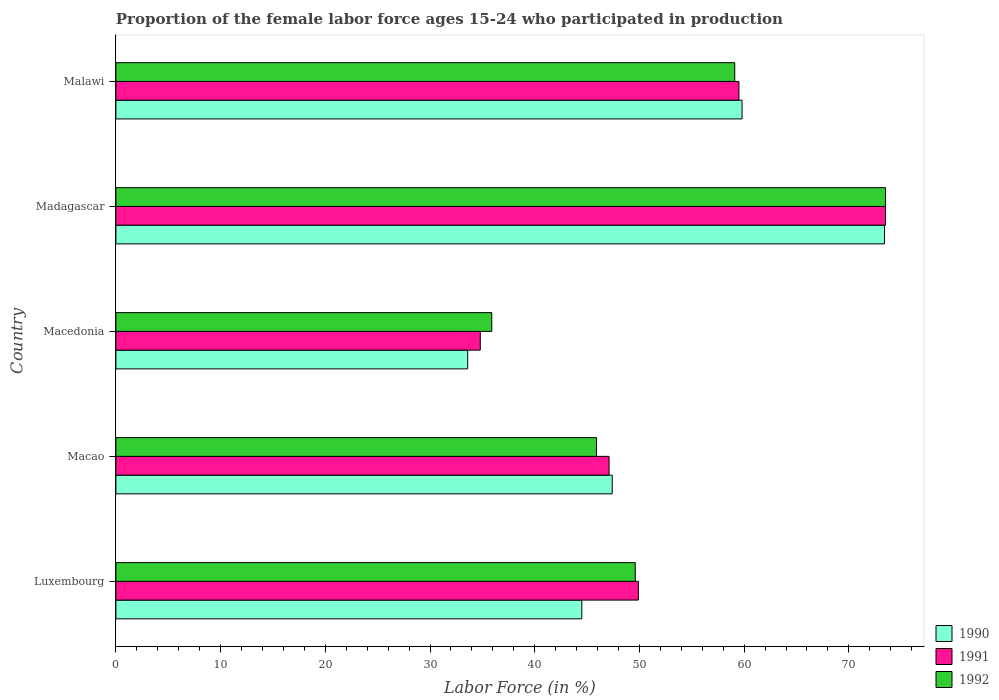Are the number of bars per tick equal to the number of legend labels?
Offer a terse response. Yes. What is the label of the 1st group of bars from the top?
Give a very brief answer. Malawi. What is the proportion of the female labor force who participated in production in 1990 in Macedonia?
Ensure brevity in your answer.  33.6. Across all countries, what is the maximum proportion of the female labor force who participated in production in 1992?
Your answer should be compact. 73.5. Across all countries, what is the minimum proportion of the female labor force who participated in production in 1992?
Provide a short and direct response. 35.9. In which country was the proportion of the female labor force who participated in production in 1990 maximum?
Make the answer very short. Madagascar. In which country was the proportion of the female labor force who participated in production in 1992 minimum?
Provide a short and direct response. Macedonia. What is the total proportion of the female labor force who participated in production in 1990 in the graph?
Give a very brief answer. 258.7. What is the difference between the proportion of the female labor force who participated in production in 1991 in Macao and that in Macedonia?
Provide a succinct answer. 12.3. What is the difference between the proportion of the female labor force who participated in production in 1992 in Malawi and the proportion of the female labor force who participated in production in 1991 in Macedonia?
Provide a short and direct response. 24.3. What is the average proportion of the female labor force who participated in production in 1990 per country?
Your response must be concise. 51.74. What is the difference between the proportion of the female labor force who participated in production in 1990 and proportion of the female labor force who participated in production in 1991 in Macedonia?
Offer a terse response. -1.2. What is the ratio of the proportion of the female labor force who participated in production in 1990 in Macao to that in Malawi?
Make the answer very short. 0.79. What is the difference between the highest and the second highest proportion of the female labor force who participated in production in 1990?
Offer a terse response. 13.6. What is the difference between the highest and the lowest proportion of the female labor force who participated in production in 1990?
Ensure brevity in your answer.  39.8. In how many countries, is the proportion of the female labor force who participated in production in 1992 greater than the average proportion of the female labor force who participated in production in 1992 taken over all countries?
Your answer should be very brief. 2. Is the sum of the proportion of the female labor force who participated in production in 1992 in Madagascar and Malawi greater than the maximum proportion of the female labor force who participated in production in 1990 across all countries?
Keep it short and to the point. Yes. What does the 3rd bar from the top in Madagascar represents?
Offer a very short reply. 1990. Is it the case that in every country, the sum of the proportion of the female labor force who participated in production in 1992 and proportion of the female labor force who participated in production in 1991 is greater than the proportion of the female labor force who participated in production in 1990?
Give a very brief answer. Yes. How many bars are there?
Make the answer very short. 15. How many countries are there in the graph?
Give a very brief answer. 5. What is the difference between two consecutive major ticks on the X-axis?
Provide a short and direct response. 10. Are the values on the major ticks of X-axis written in scientific E-notation?
Offer a terse response. No. Does the graph contain any zero values?
Give a very brief answer. No. Does the graph contain grids?
Your answer should be very brief. No. Where does the legend appear in the graph?
Your answer should be compact. Bottom right. How many legend labels are there?
Make the answer very short. 3. How are the legend labels stacked?
Make the answer very short. Vertical. What is the title of the graph?
Give a very brief answer. Proportion of the female labor force ages 15-24 who participated in production. Does "1969" appear as one of the legend labels in the graph?
Keep it short and to the point. No. What is the label or title of the X-axis?
Your answer should be compact. Labor Force (in %). What is the label or title of the Y-axis?
Make the answer very short. Country. What is the Labor Force (in %) of 1990 in Luxembourg?
Offer a terse response. 44.5. What is the Labor Force (in %) of 1991 in Luxembourg?
Provide a short and direct response. 49.9. What is the Labor Force (in %) of 1992 in Luxembourg?
Your response must be concise. 49.6. What is the Labor Force (in %) in 1990 in Macao?
Make the answer very short. 47.4. What is the Labor Force (in %) in 1991 in Macao?
Offer a terse response. 47.1. What is the Labor Force (in %) of 1992 in Macao?
Give a very brief answer. 45.9. What is the Labor Force (in %) of 1990 in Macedonia?
Make the answer very short. 33.6. What is the Labor Force (in %) in 1991 in Macedonia?
Give a very brief answer. 34.8. What is the Labor Force (in %) in 1992 in Macedonia?
Provide a short and direct response. 35.9. What is the Labor Force (in %) in 1990 in Madagascar?
Ensure brevity in your answer.  73.4. What is the Labor Force (in %) in 1991 in Madagascar?
Provide a short and direct response. 73.5. What is the Labor Force (in %) in 1992 in Madagascar?
Your answer should be very brief. 73.5. What is the Labor Force (in %) of 1990 in Malawi?
Your response must be concise. 59.8. What is the Labor Force (in %) in 1991 in Malawi?
Give a very brief answer. 59.5. What is the Labor Force (in %) in 1992 in Malawi?
Give a very brief answer. 59.1. Across all countries, what is the maximum Labor Force (in %) in 1990?
Provide a short and direct response. 73.4. Across all countries, what is the maximum Labor Force (in %) in 1991?
Provide a short and direct response. 73.5. Across all countries, what is the maximum Labor Force (in %) in 1992?
Your answer should be compact. 73.5. Across all countries, what is the minimum Labor Force (in %) in 1990?
Keep it short and to the point. 33.6. Across all countries, what is the minimum Labor Force (in %) of 1991?
Give a very brief answer. 34.8. Across all countries, what is the minimum Labor Force (in %) in 1992?
Your response must be concise. 35.9. What is the total Labor Force (in %) of 1990 in the graph?
Provide a short and direct response. 258.7. What is the total Labor Force (in %) of 1991 in the graph?
Give a very brief answer. 264.8. What is the total Labor Force (in %) of 1992 in the graph?
Provide a succinct answer. 264. What is the difference between the Labor Force (in %) in 1990 in Luxembourg and that in Macao?
Keep it short and to the point. -2.9. What is the difference between the Labor Force (in %) in 1991 in Luxembourg and that in Macao?
Your response must be concise. 2.8. What is the difference between the Labor Force (in %) of 1990 in Luxembourg and that in Macedonia?
Make the answer very short. 10.9. What is the difference between the Labor Force (in %) in 1991 in Luxembourg and that in Macedonia?
Give a very brief answer. 15.1. What is the difference between the Labor Force (in %) in 1990 in Luxembourg and that in Madagascar?
Provide a short and direct response. -28.9. What is the difference between the Labor Force (in %) of 1991 in Luxembourg and that in Madagascar?
Offer a terse response. -23.6. What is the difference between the Labor Force (in %) in 1992 in Luxembourg and that in Madagascar?
Keep it short and to the point. -23.9. What is the difference between the Labor Force (in %) of 1990 in Luxembourg and that in Malawi?
Provide a short and direct response. -15.3. What is the difference between the Labor Force (in %) in 1991 in Luxembourg and that in Malawi?
Provide a succinct answer. -9.6. What is the difference between the Labor Force (in %) of 1992 in Luxembourg and that in Malawi?
Make the answer very short. -9.5. What is the difference between the Labor Force (in %) in 1991 in Macao and that in Macedonia?
Your answer should be very brief. 12.3. What is the difference between the Labor Force (in %) in 1990 in Macao and that in Madagascar?
Ensure brevity in your answer.  -26. What is the difference between the Labor Force (in %) of 1991 in Macao and that in Madagascar?
Provide a succinct answer. -26.4. What is the difference between the Labor Force (in %) of 1992 in Macao and that in Madagascar?
Make the answer very short. -27.6. What is the difference between the Labor Force (in %) in 1990 in Macao and that in Malawi?
Your response must be concise. -12.4. What is the difference between the Labor Force (in %) of 1991 in Macao and that in Malawi?
Provide a short and direct response. -12.4. What is the difference between the Labor Force (in %) of 1990 in Macedonia and that in Madagascar?
Keep it short and to the point. -39.8. What is the difference between the Labor Force (in %) of 1991 in Macedonia and that in Madagascar?
Provide a succinct answer. -38.7. What is the difference between the Labor Force (in %) of 1992 in Macedonia and that in Madagascar?
Provide a short and direct response. -37.6. What is the difference between the Labor Force (in %) of 1990 in Macedonia and that in Malawi?
Make the answer very short. -26.2. What is the difference between the Labor Force (in %) in 1991 in Macedonia and that in Malawi?
Provide a succinct answer. -24.7. What is the difference between the Labor Force (in %) of 1992 in Macedonia and that in Malawi?
Keep it short and to the point. -23.2. What is the difference between the Labor Force (in %) of 1991 in Madagascar and that in Malawi?
Your answer should be compact. 14. What is the difference between the Labor Force (in %) in 1992 in Madagascar and that in Malawi?
Offer a terse response. 14.4. What is the difference between the Labor Force (in %) in 1990 in Luxembourg and the Labor Force (in %) in 1992 in Macedonia?
Ensure brevity in your answer.  8.6. What is the difference between the Labor Force (in %) in 1991 in Luxembourg and the Labor Force (in %) in 1992 in Macedonia?
Give a very brief answer. 14. What is the difference between the Labor Force (in %) in 1990 in Luxembourg and the Labor Force (in %) in 1992 in Madagascar?
Your answer should be compact. -29. What is the difference between the Labor Force (in %) in 1991 in Luxembourg and the Labor Force (in %) in 1992 in Madagascar?
Provide a short and direct response. -23.6. What is the difference between the Labor Force (in %) in 1990 in Luxembourg and the Labor Force (in %) in 1991 in Malawi?
Offer a very short reply. -15. What is the difference between the Labor Force (in %) of 1990 in Luxembourg and the Labor Force (in %) of 1992 in Malawi?
Give a very brief answer. -14.6. What is the difference between the Labor Force (in %) in 1991 in Luxembourg and the Labor Force (in %) in 1992 in Malawi?
Ensure brevity in your answer.  -9.2. What is the difference between the Labor Force (in %) of 1990 in Macao and the Labor Force (in %) of 1992 in Macedonia?
Your answer should be very brief. 11.5. What is the difference between the Labor Force (in %) in 1991 in Macao and the Labor Force (in %) in 1992 in Macedonia?
Your response must be concise. 11.2. What is the difference between the Labor Force (in %) in 1990 in Macao and the Labor Force (in %) in 1991 in Madagascar?
Make the answer very short. -26.1. What is the difference between the Labor Force (in %) in 1990 in Macao and the Labor Force (in %) in 1992 in Madagascar?
Your response must be concise. -26.1. What is the difference between the Labor Force (in %) in 1991 in Macao and the Labor Force (in %) in 1992 in Madagascar?
Provide a short and direct response. -26.4. What is the difference between the Labor Force (in %) of 1990 in Macao and the Labor Force (in %) of 1991 in Malawi?
Offer a very short reply. -12.1. What is the difference between the Labor Force (in %) of 1990 in Macao and the Labor Force (in %) of 1992 in Malawi?
Your answer should be compact. -11.7. What is the difference between the Labor Force (in %) in 1990 in Macedonia and the Labor Force (in %) in 1991 in Madagascar?
Keep it short and to the point. -39.9. What is the difference between the Labor Force (in %) in 1990 in Macedonia and the Labor Force (in %) in 1992 in Madagascar?
Provide a succinct answer. -39.9. What is the difference between the Labor Force (in %) in 1991 in Macedonia and the Labor Force (in %) in 1992 in Madagascar?
Your answer should be very brief. -38.7. What is the difference between the Labor Force (in %) in 1990 in Macedonia and the Labor Force (in %) in 1991 in Malawi?
Your answer should be very brief. -25.9. What is the difference between the Labor Force (in %) in 1990 in Macedonia and the Labor Force (in %) in 1992 in Malawi?
Keep it short and to the point. -25.5. What is the difference between the Labor Force (in %) in 1991 in Macedonia and the Labor Force (in %) in 1992 in Malawi?
Your answer should be very brief. -24.3. What is the difference between the Labor Force (in %) of 1991 in Madagascar and the Labor Force (in %) of 1992 in Malawi?
Your answer should be very brief. 14.4. What is the average Labor Force (in %) in 1990 per country?
Give a very brief answer. 51.74. What is the average Labor Force (in %) of 1991 per country?
Provide a succinct answer. 52.96. What is the average Labor Force (in %) in 1992 per country?
Your answer should be compact. 52.8. What is the difference between the Labor Force (in %) of 1990 and Labor Force (in %) of 1991 in Luxembourg?
Make the answer very short. -5.4. What is the difference between the Labor Force (in %) of 1990 and Labor Force (in %) of 1991 in Macao?
Your response must be concise. 0.3. What is the difference between the Labor Force (in %) in 1991 and Labor Force (in %) in 1992 in Macao?
Keep it short and to the point. 1.2. What is the difference between the Labor Force (in %) in 1990 and Labor Force (in %) in 1992 in Macedonia?
Your answer should be very brief. -2.3. What is the difference between the Labor Force (in %) in 1991 and Labor Force (in %) in 1992 in Macedonia?
Offer a terse response. -1.1. What is the difference between the Labor Force (in %) of 1991 and Labor Force (in %) of 1992 in Madagascar?
Offer a very short reply. 0. What is the difference between the Labor Force (in %) of 1990 and Labor Force (in %) of 1991 in Malawi?
Your response must be concise. 0.3. What is the ratio of the Labor Force (in %) in 1990 in Luxembourg to that in Macao?
Ensure brevity in your answer.  0.94. What is the ratio of the Labor Force (in %) in 1991 in Luxembourg to that in Macao?
Keep it short and to the point. 1.06. What is the ratio of the Labor Force (in %) in 1992 in Luxembourg to that in Macao?
Your response must be concise. 1.08. What is the ratio of the Labor Force (in %) in 1990 in Luxembourg to that in Macedonia?
Ensure brevity in your answer.  1.32. What is the ratio of the Labor Force (in %) of 1991 in Luxembourg to that in Macedonia?
Your response must be concise. 1.43. What is the ratio of the Labor Force (in %) in 1992 in Luxembourg to that in Macedonia?
Your answer should be very brief. 1.38. What is the ratio of the Labor Force (in %) in 1990 in Luxembourg to that in Madagascar?
Give a very brief answer. 0.61. What is the ratio of the Labor Force (in %) of 1991 in Luxembourg to that in Madagascar?
Give a very brief answer. 0.68. What is the ratio of the Labor Force (in %) of 1992 in Luxembourg to that in Madagascar?
Ensure brevity in your answer.  0.67. What is the ratio of the Labor Force (in %) in 1990 in Luxembourg to that in Malawi?
Make the answer very short. 0.74. What is the ratio of the Labor Force (in %) in 1991 in Luxembourg to that in Malawi?
Offer a terse response. 0.84. What is the ratio of the Labor Force (in %) in 1992 in Luxembourg to that in Malawi?
Ensure brevity in your answer.  0.84. What is the ratio of the Labor Force (in %) in 1990 in Macao to that in Macedonia?
Ensure brevity in your answer.  1.41. What is the ratio of the Labor Force (in %) of 1991 in Macao to that in Macedonia?
Ensure brevity in your answer.  1.35. What is the ratio of the Labor Force (in %) in 1992 in Macao to that in Macedonia?
Ensure brevity in your answer.  1.28. What is the ratio of the Labor Force (in %) in 1990 in Macao to that in Madagascar?
Offer a terse response. 0.65. What is the ratio of the Labor Force (in %) of 1991 in Macao to that in Madagascar?
Give a very brief answer. 0.64. What is the ratio of the Labor Force (in %) of 1992 in Macao to that in Madagascar?
Your response must be concise. 0.62. What is the ratio of the Labor Force (in %) in 1990 in Macao to that in Malawi?
Give a very brief answer. 0.79. What is the ratio of the Labor Force (in %) in 1991 in Macao to that in Malawi?
Provide a short and direct response. 0.79. What is the ratio of the Labor Force (in %) in 1992 in Macao to that in Malawi?
Ensure brevity in your answer.  0.78. What is the ratio of the Labor Force (in %) in 1990 in Macedonia to that in Madagascar?
Your answer should be compact. 0.46. What is the ratio of the Labor Force (in %) of 1991 in Macedonia to that in Madagascar?
Provide a short and direct response. 0.47. What is the ratio of the Labor Force (in %) in 1992 in Macedonia to that in Madagascar?
Your response must be concise. 0.49. What is the ratio of the Labor Force (in %) of 1990 in Macedonia to that in Malawi?
Provide a short and direct response. 0.56. What is the ratio of the Labor Force (in %) of 1991 in Macedonia to that in Malawi?
Give a very brief answer. 0.58. What is the ratio of the Labor Force (in %) of 1992 in Macedonia to that in Malawi?
Ensure brevity in your answer.  0.61. What is the ratio of the Labor Force (in %) of 1990 in Madagascar to that in Malawi?
Offer a terse response. 1.23. What is the ratio of the Labor Force (in %) of 1991 in Madagascar to that in Malawi?
Your answer should be compact. 1.24. What is the ratio of the Labor Force (in %) in 1992 in Madagascar to that in Malawi?
Provide a succinct answer. 1.24. What is the difference between the highest and the second highest Labor Force (in %) of 1990?
Give a very brief answer. 13.6. What is the difference between the highest and the lowest Labor Force (in %) of 1990?
Ensure brevity in your answer.  39.8. What is the difference between the highest and the lowest Labor Force (in %) of 1991?
Make the answer very short. 38.7. What is the difference between the highest and the lowest Labor Force (in %) in 1992?
Your response must be concise. 37.6. 